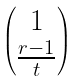<formula> <loc_0><loc_0><loc_500><loc_500>\begin{pmatrix} 1 \\ \frac { r - 1 } { t } \\ \end{pmatrix}</formula> 